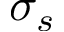<formula> <loc_0><loc_0><loc_500><loc_500>\sigma _ { s }</formula> 